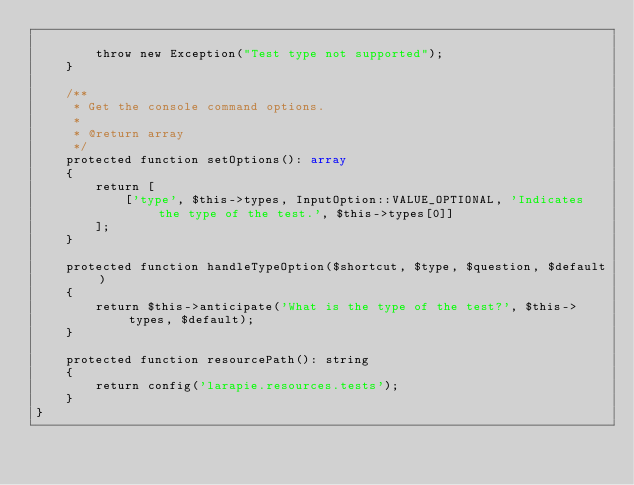Convert code to text. <code><loc_0><loc_0><loc_500><loc_500><_PHP_>
        throw new Exception("Test type not supported");
    }

    /**
     * Get the console command options.
     *
     * @return array
     */
    protected function setOptions(): array
    {
        return [
            ['type', $this->types, InputOption::VALUE_OPTIONAL, 'Indicates the type of the test.', $this->types[0]]
        ];
    }

    protected function handleTypeOption($shortcut, $type, $question, $default)
    {
        return $this->anticipate('What is the type of the test?', $this->types, $default);
    }

    protected function resourcePath(): string
    {
        return config('larapie.resources.tests');
    }
}
</code> 